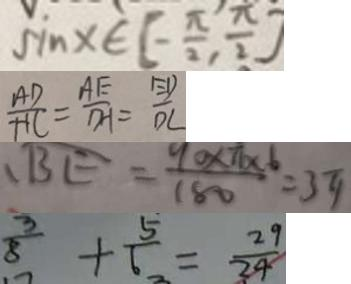<formula> <loc_0><loc_0><loc_500><loc_500>\sin x \in [ - \frac { \pi } { 2 } , \frac { \pi } { 2 } ] 
 \frac { A D } { H C } = \frac { A E } { D H } = \frac { E D } { D C } 
 、 B E = \frac { 9 0 \times \pi \times 6 } { 1 8 0 } = 3 \pi 
 \frac { 3 } { 8 } + \frac { 5 } { 6 } = \frac { 2 9 } { 2 4 }</formula> 